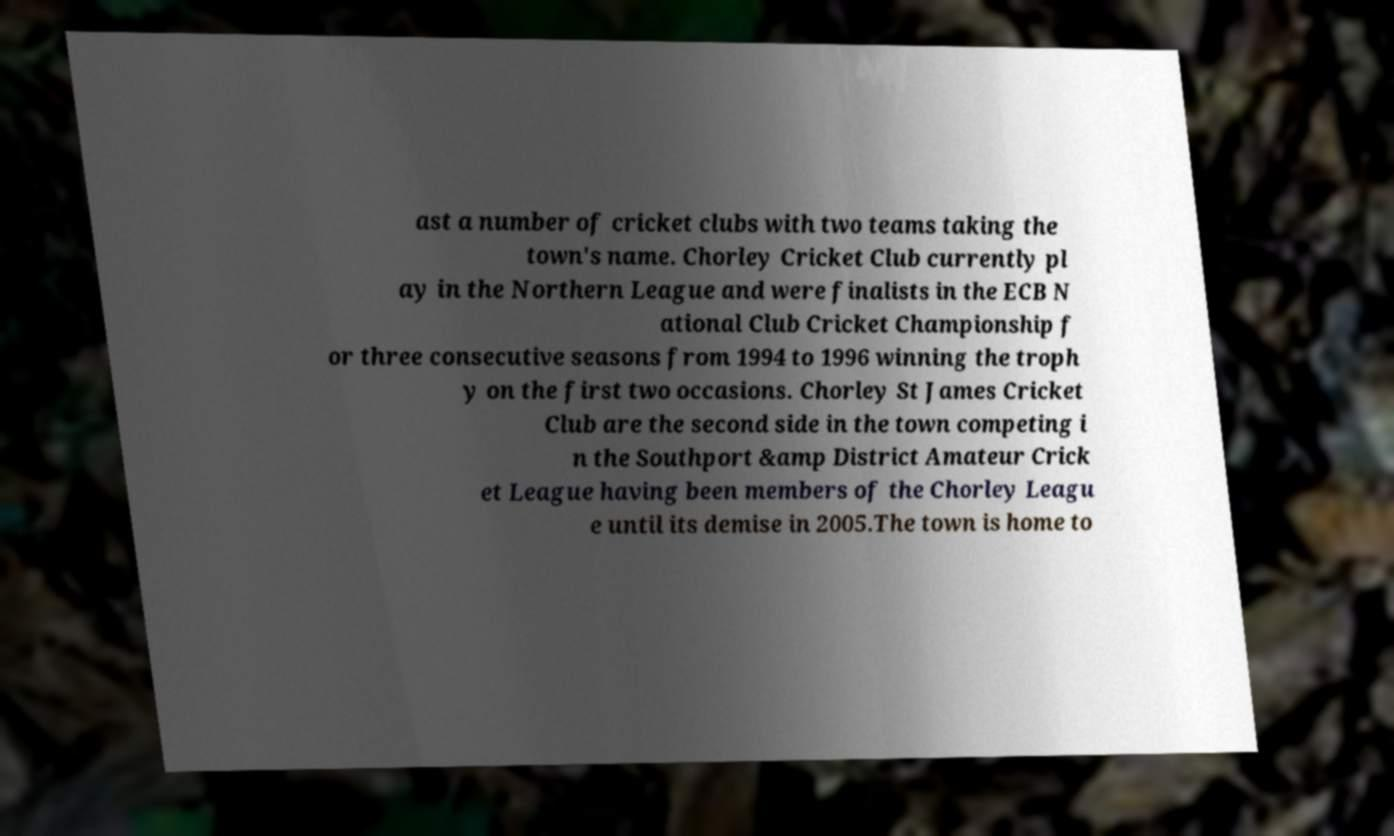Could you assist in decoding the text presented in this image and type it out clearly? ast a number of cricket clubs with two teams taking the town's name. Chorley Cricket Club currently pl ay in the Northern League and were finalists in the ECB N ational Club Cricket Championship f or three consecutive seasons from 1994 to 1996 winning the troph y on the first two occasions. Chorley St James Cricket Club are the second side in the town competing i n the Southport &amp District Amateur Crick et League having been members of the Chorley Leagu e until its demise in 2005.The town is home to 